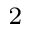<formula> <loc_0><loc_0><loc_500><loc_500>_ { 2 }</formula> 